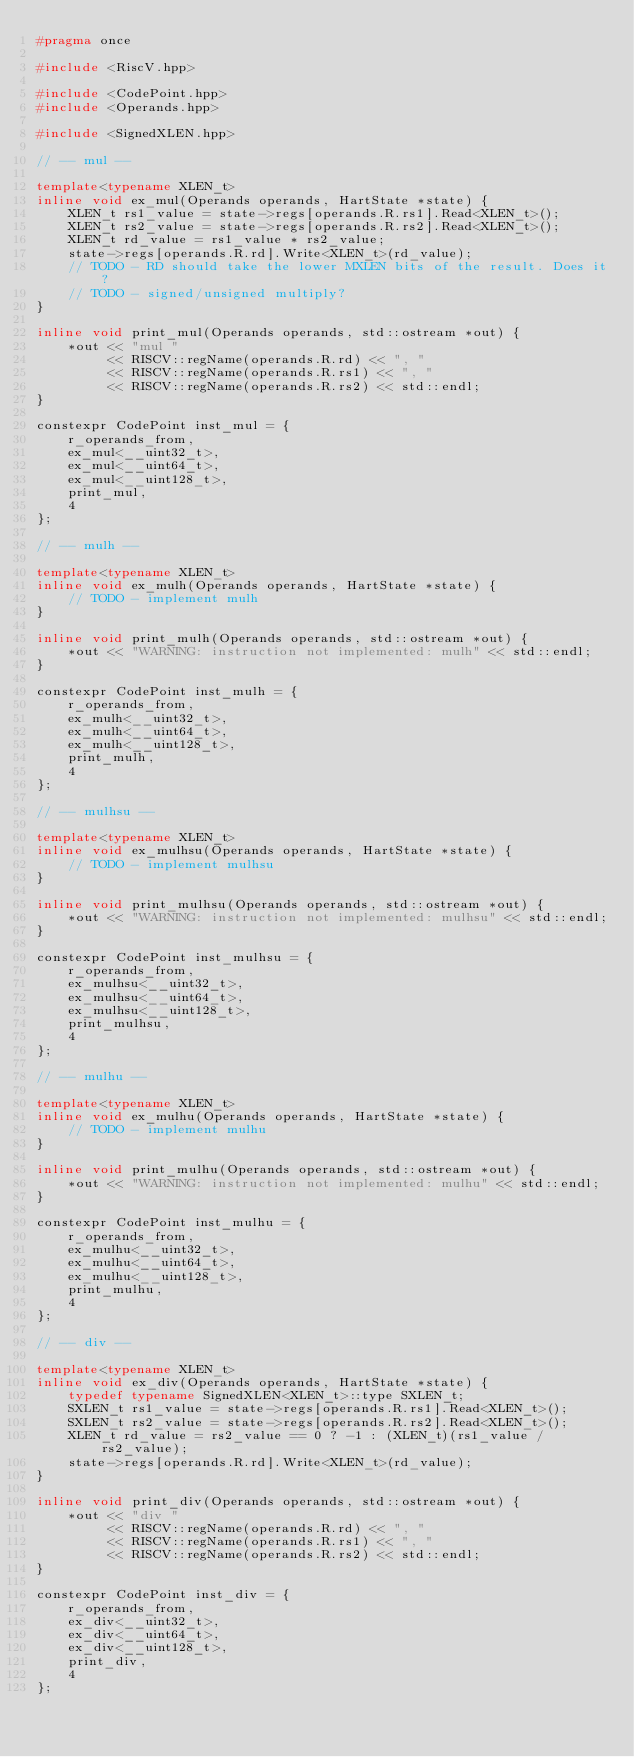<code> <loc_0><loc_0><loc_500><loc_500><_C++_>#pragma once

#include <RiscV.hpp>

#include <CodePoint.hpp>
#include <Operands.hpp>

#include <SignedXLEN.hpp>

// -- mul --

template<typename XLEN_t>
inline void ex_mul(Operands operands, HartState *state) {
    XLEN_t rs1_value = state->regs[operands.R.rs1].Read<XLEN_t>();
    XLEN_t rs2_value = state->regs[operands.R.rs2].Read<XLEN_t>();
    XLEN_t rd_value = rs1_value * rs2_value;
    state->regs[operands.R.rd].Write<XLEN_t>(rd_value);
    // TODO - RD should take the lower MXLEN bits of the result. Does it?
    // TODO - signed/unsigned multiply?
}

inline void print_mul(Operands operands, std::ostream *out) {
    *out << "mul "
         << RISCV::regName(operands.R.rd) << ", "
         << RISCV::regName(operands.R.rs1) << ", "
         << RISCV::regName(operands.R.rs2) << std::endl;
}

constexpr CodePoint inst_mul = {
    r_operands_from,
    ex_mul<__uint32_t>,
    ex_mul<__uint64_t>,
    ex_mul<__uint128_t>,
    print_mul,
    4
};

// -- mulh --

template<typename XLEN_t>
inline void ex_mulh(Operands operands, HartState *state) {
    // TODO - implement mulh
}

inline void print_mulh(Operands operands, std::ostream *out) {
    *out << "WARNING: instruction not implemented: mulh" << std::endl;
}

constexpr CodePoint inst_mulh = {
    r_operands_from,
    ex_mulh<__uint32_t>,
    ex_mulh<__uint64_t>,
    ex_mulh<__uint128_t>,
    print_mulh,
    4
};

// -- mulhsu --

template<typename XLEN_t>
inline void ex_mulhsu(Operands operands, HartState *state) {
    // TODO - implement mulhsu
}

inline void print_mulhsu(Operands operands, std::ostream *out) {
    *out << "WARNING: instruction not implemented: mulhsu" << std::endl;
}

constexpr CodePoint inst_mulhsu = {
    r_operands_from,
    ex_mulhsu<__uint32_t>,
    ex_mulhsu<__uint64_t>,
    ex_mulhsu<__uint128_t>,
    print_mulhsu,
    4
};

// -- mulhu --

template<typename XLEN_t>
inline void ex_mulhu(Operands operands, HartState *state) {
    // TODO - implement mulhu
}

inline void print_mulhu(Operands operands, std::ostream *out) {
    *out << "WARNING: instruction not implemented: mulhu" << std::endl;
}

constexpr CodePoint inst_mulhu = {
    r_operands_from,
    ex_mulhu<__uint32_t>,
    ex_mulhu<__uint64_t>,
    ex_mulhu<__uint128_t>,
    print_mulhu,
    4
};

// -- div --

template<typename XLEN_t>
inline void ex_div(Operands operands, HartState *state) {
    typedef typename SignedXLEN<XLEN_t>::type SXLEN_t;
    SXLEN_t rs1_value = state->regs[operands.R.rs1].Read<XLEN_t>();
    SXLEN_t rs2_value = state->regs[operands.R.rs2].Read<XLEN_t>();
    XLEN_t rd_value = rs2_value == 0 ? -1 : (XLEN_t)(rs1_value / rs2_value);
    state->regs[operands.R.rd].Write<XLEN_t>(rd_value);
}

inline void print_div(Operands operands, std::ostream *out) {
    *out << "div "
         << RISCV::regName(operands.R.rd) << ", "
         << RISCV::regName(operands.R.rs1) << ", "
         << RISCV::regName(operands.R.rs2) << std::endl;
}

constexpr CodePoint inst_div = {
    r_operands_from,
    ex_div<__uint32_t>,
    ex_div<__uint64_t>,
    ex_div<__uint128_t>,
    print_div,
    4
};
</code> 